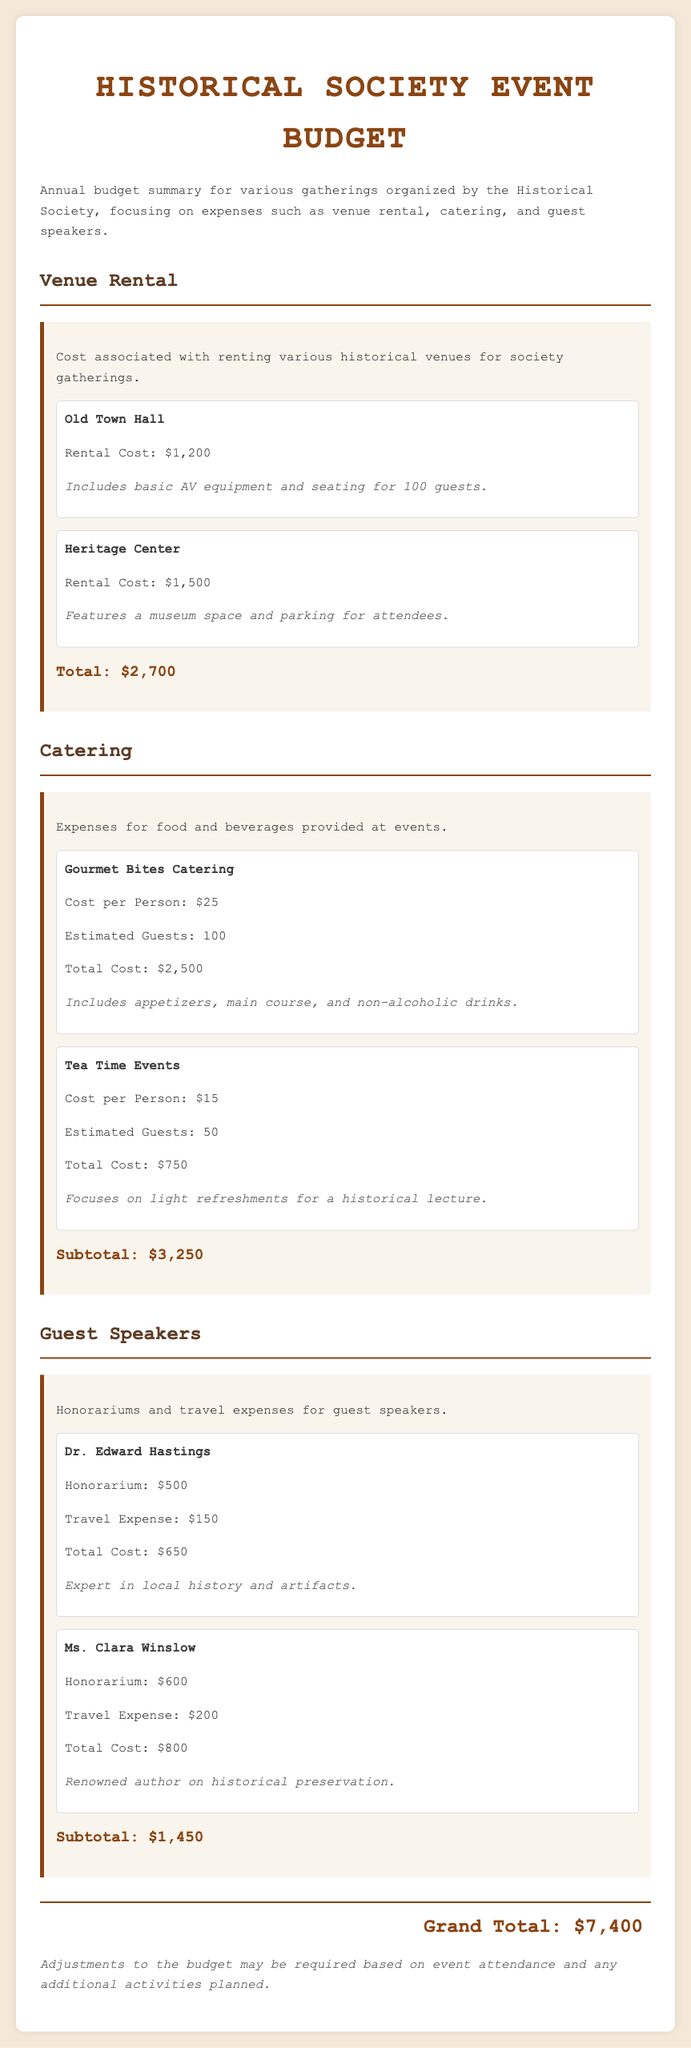What is the total cost for venue rental? The total cost for venue rental is summed from the individual rental costs listed for Old Town Hall and Heritage Center.
Answer: $2,700 What is the estimated cost for catering at Gourmet Bites Catering? The total cost for catering at Gourmet Bites Catering is calculated based on the cost per person and the estimated number of guests.
Answer: $2,500 Who is the guest speaker with the highest total cost? The individual costs for guest speakers are tallied, and Ms. Clara Winslow has the highest total cost among them.
Answer: Ms. Clara Winslow What is the honorarium for Dr. Edward Hastings? The document specifies the honorarium amount for Dr. Edward Hastings, which contributes to his total cost.
Answer: $500 What is the grand total for the annual budget? The grand total sums all the expenses across the categories of venue rental, catering, and guest speakers.
Answer: $7,400 What is the estimated number of guests for Tea Time Events? The document provides the estimated guest count specifically mentioned for Tea Time Events.
Answer: 50 What features does the Heritage Center rental include? The notes provided about the Heritage Center describe what is included in the rental.
Answer: A museum space and parking for attendees What is the cost per person for the catering service of Tea Time Events? The document details the cost per person for the Tea Time Events catering option in the catering section.
Answer: $15 What are the travel expenses for Ms. Clara Winslow? The total expense related to travel for Ms. Clara Winslow provides specific information listed in the document.
Answer: $200 